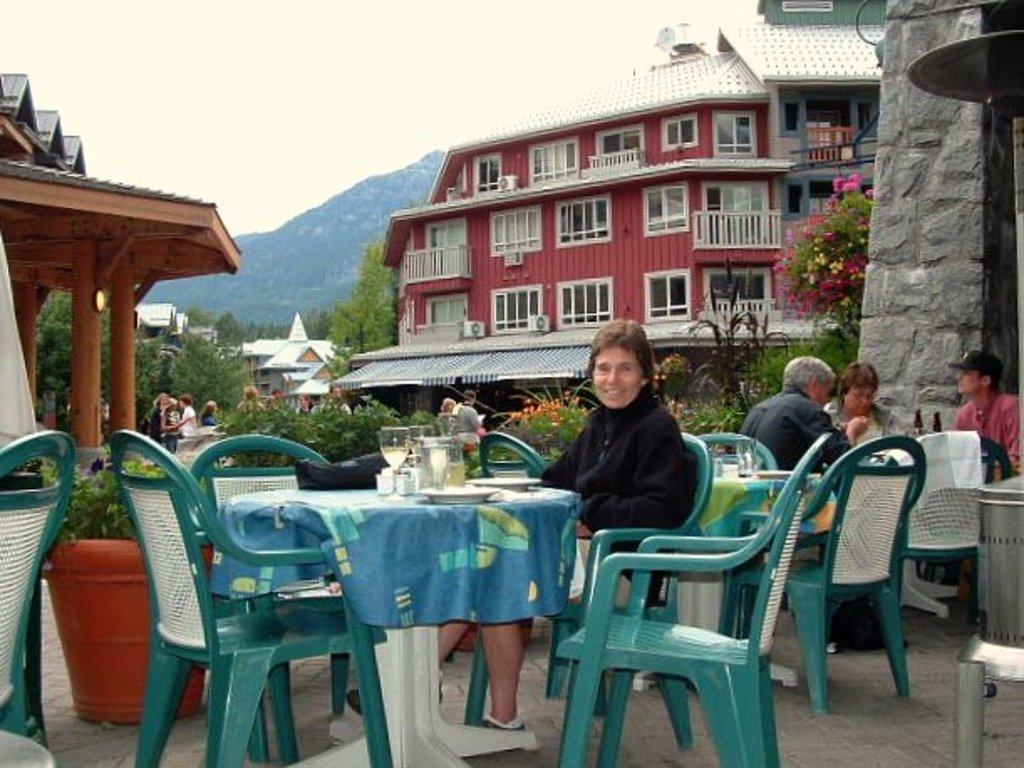In one or two sentences, can you explain what this image depicts? It seems to be the image is taken in a restaurant. In the image there are few people are sitting on chair in front of a table, on table we can see a cloth,plate,glass,jar. In background we can see group of people standing and walking and we can also see a building, windows. On right side there are some trees,flowers and left side also we can see some trees and buildings. In background there is mountain and sky is on top. 